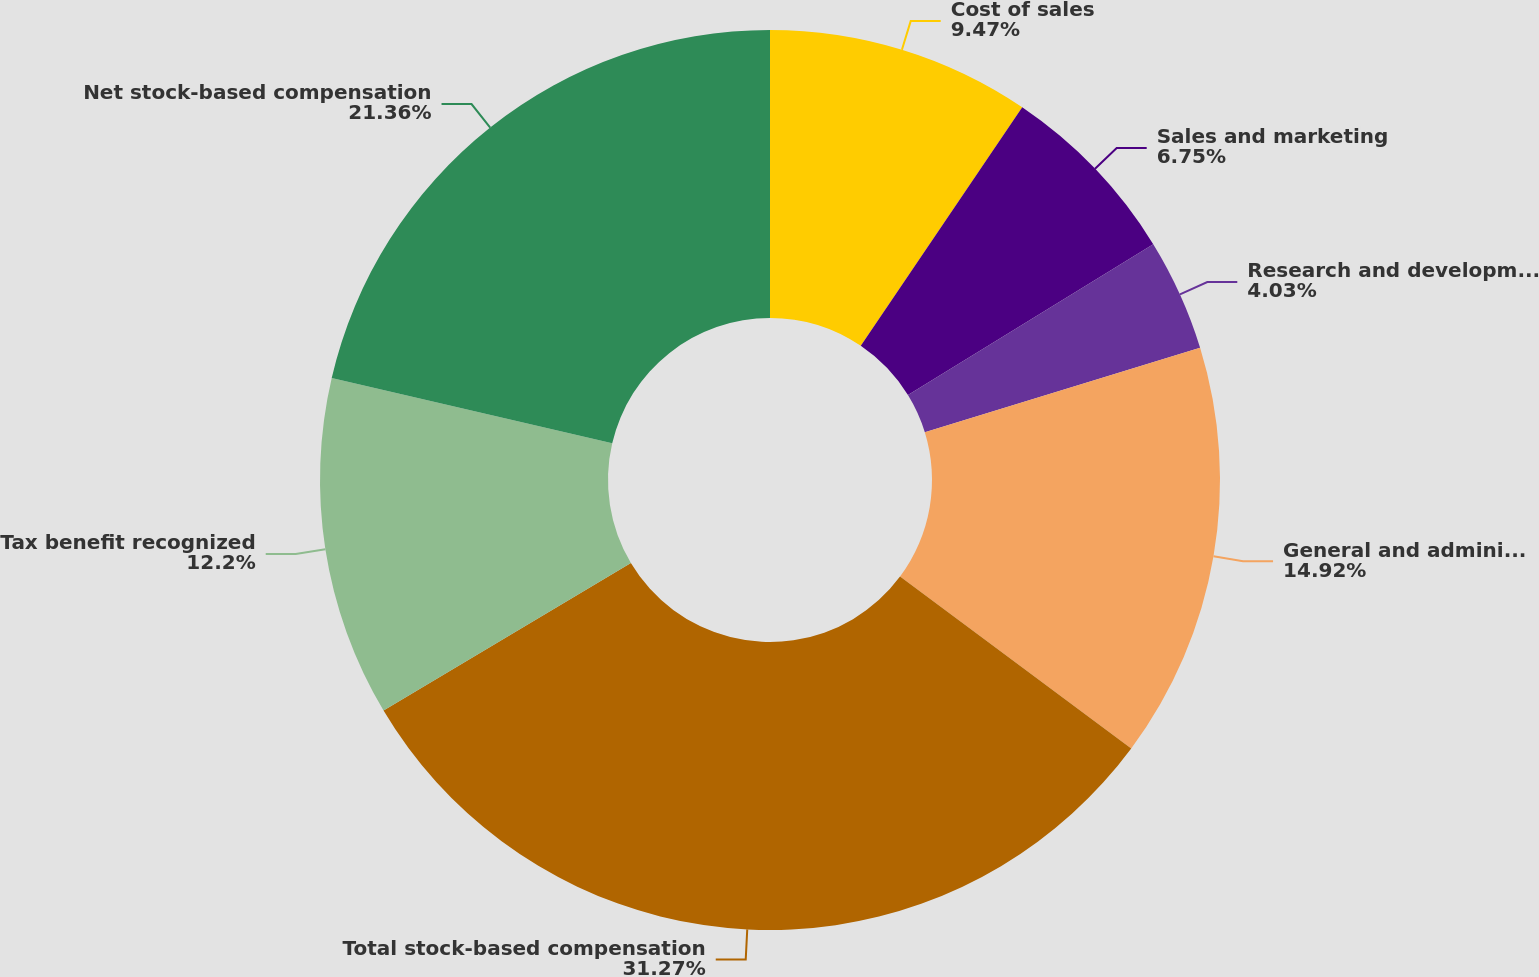Convert chart to OTSL. <chart><loc_0><loc_0><loc_500><loc_500><pie_chart><fcel>Cost of sales<fcel>Sales and marketing<fcel>Research and development<fcel>General and administrative<fcel>Total stock-based compensation<fcel>Tax benefit recognized<fcel>Net stock-based compensation<nl><fcel>9.47%<fcel>6.75%<fcel>4.03%<fcel>14.92%<fcel>31.27%<fcel>12.2%<fcel>21.36%<nl></chart> 